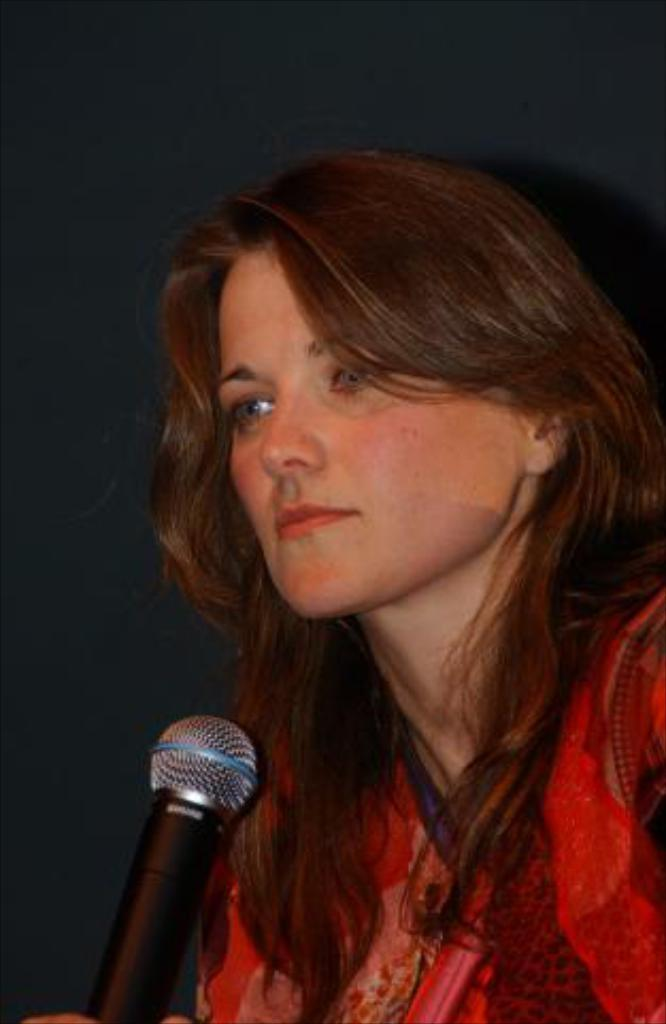What is the main subject of the image? The main subject of the image is a woman. What is the woman holding in the image? The woman is holding a microphone. What is the woman wearing in the image? The woman is wearing a red dress. Can you see any knives in the image? There are no knives visible in the image. Is the woman taking a bath in the image? There is no indication of a bath or any bath-related items in the image. Is the woman standing near a harbor in the image? There is no reference to a harbor or any waterfront area in the image. 